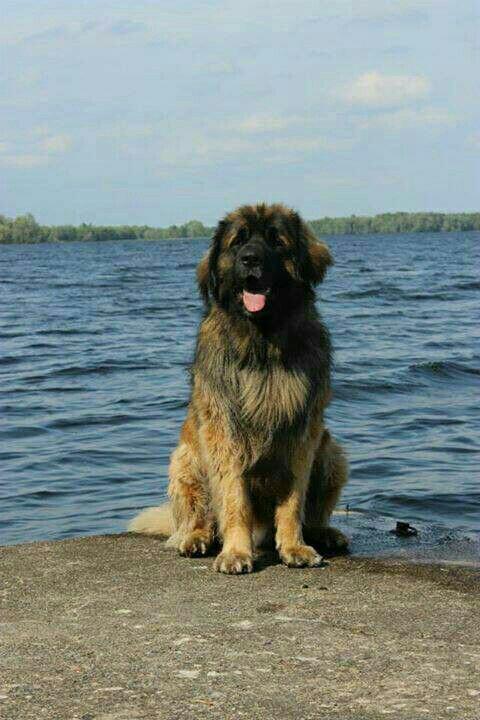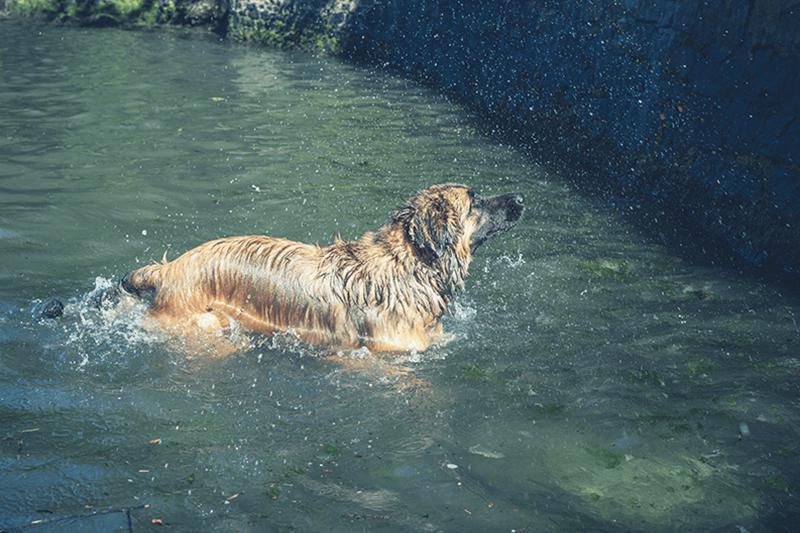The first image is the image on the left, the second image is the image on the right. Evaluate the accuracy of this statement regarding the images: "The dog in the right image is in water facing towards the left.". Is it true? Answer yes or no. No. 